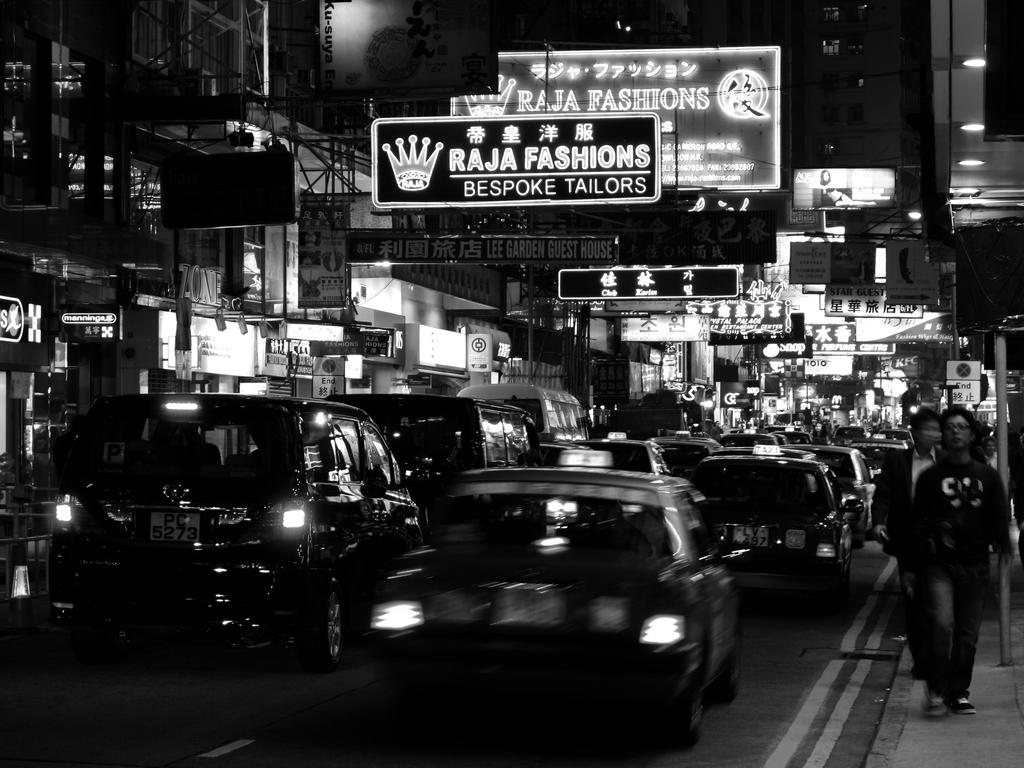Provide a one-sentence caption for the provided image. A sign for Raja Fashions features an image of a crown. 